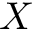Convert formula to latex. <formula><loc_0><loc_0><loc_500><loc_500>X</formula> 